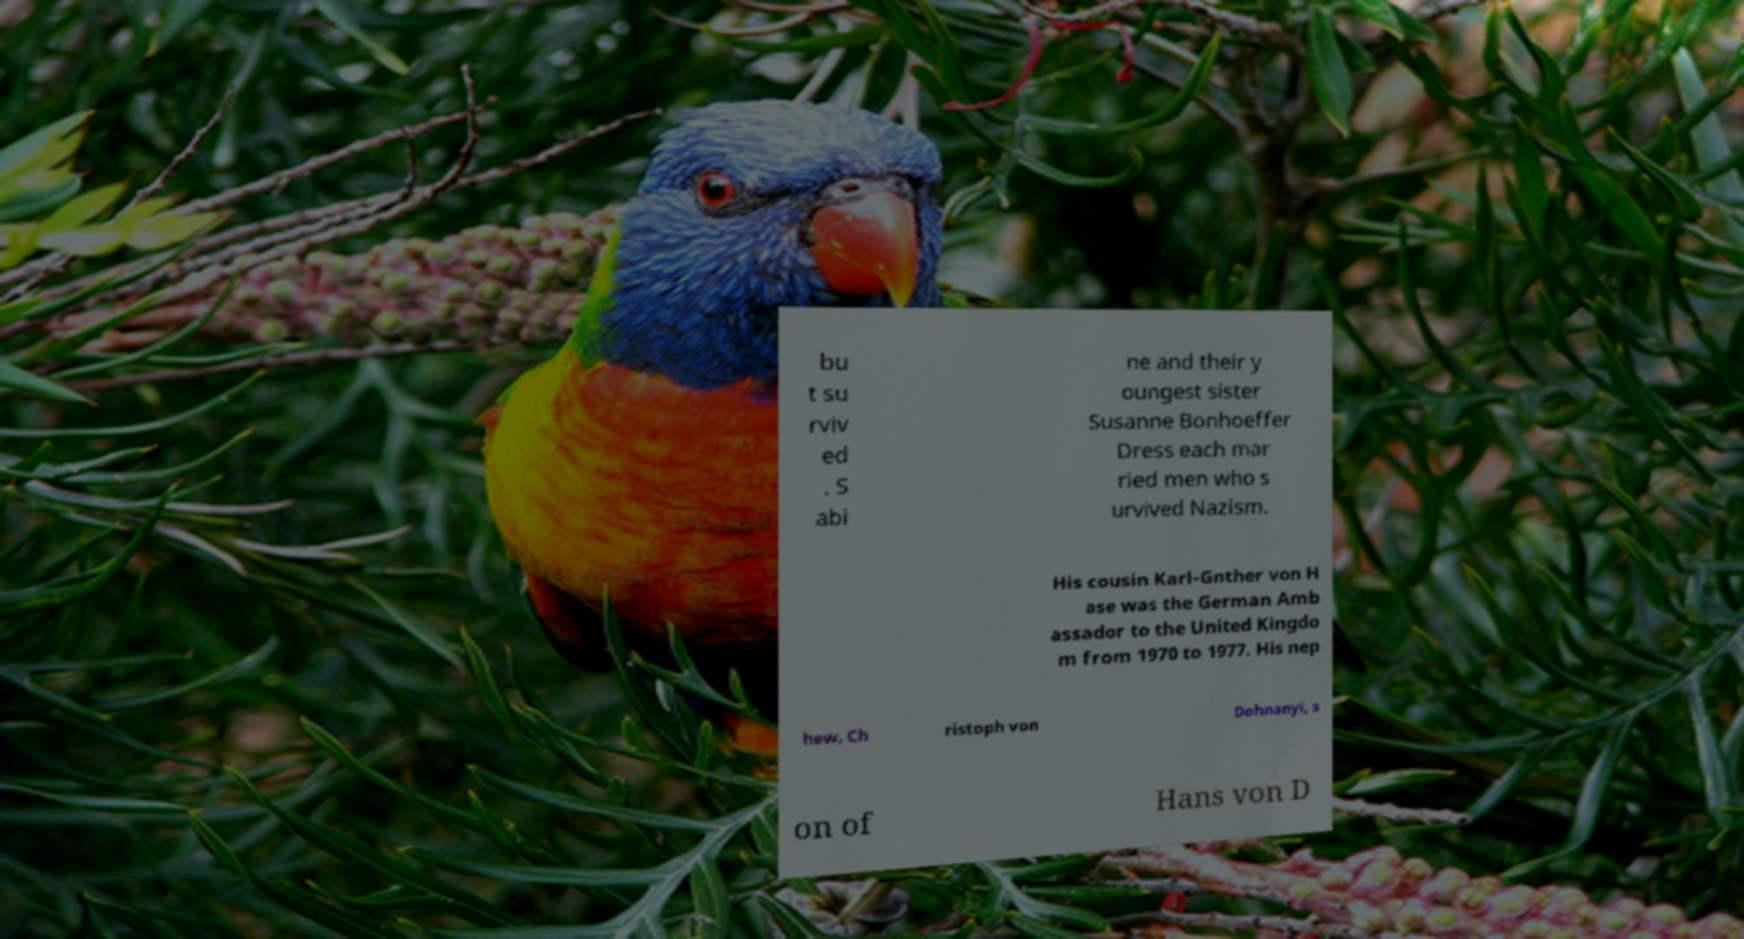For documentation purposes, I need the text within this image transcribed. Could you provide that? bu t su rviv ed . S abi ne and their y oungest sister Susanne Bonhoeffer Dress each mar ried men who s urvived Nazism. His cousin Karl-Gnther von H ase was the German Amb assador to the United Kingdo m from 1970 to 1977. His nep hew, Ch ristoph von Dohnanyi, s on of Hans von D 